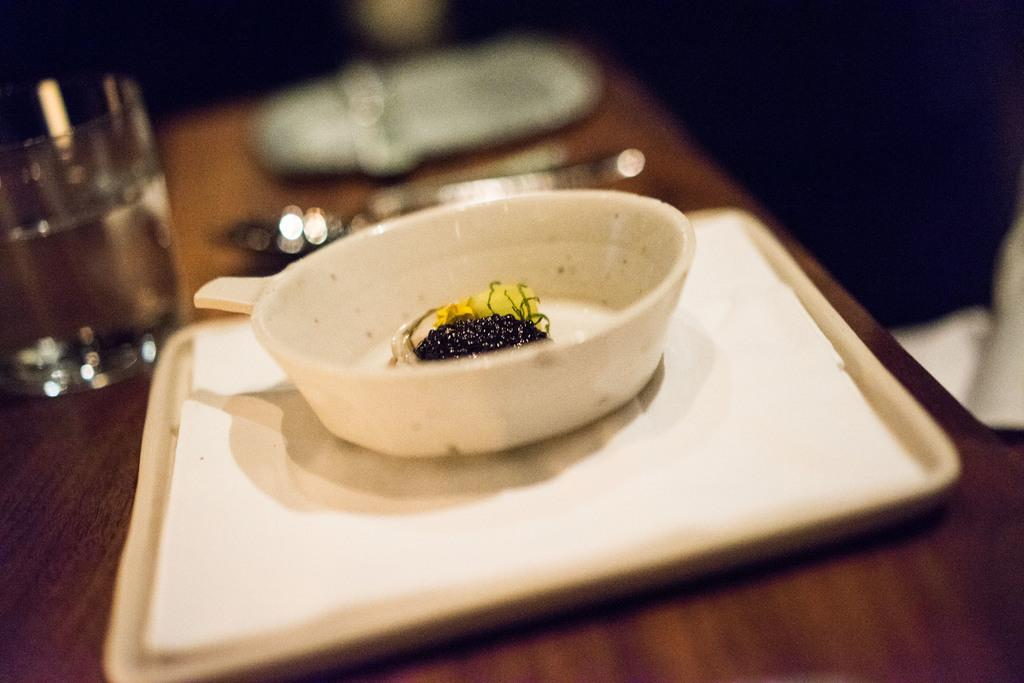What type of dishware can be seen in the image? There is a plate, a glass, and a bowl in the image. What is the color of the table in the image? The table in the image is brown in color. Can you describe the background of the image? The background of the image is blurred. What type of farmer is visible in the image? There is no farmer present in the image. What does the knee of the person in the image look like? There is no person present in the image, so it is not possible to describe their knee. 